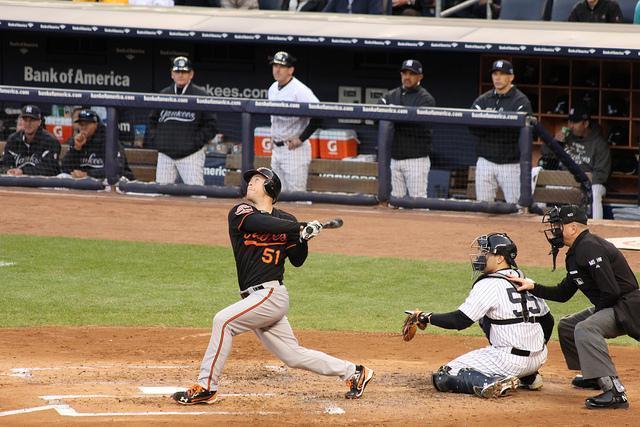How many teams are shown in this image?
Give a very brief answer. 2. How many people can you see?
Give a very brief answer. 10. How many giraffes are there?
Give a very brief answer. 0. 